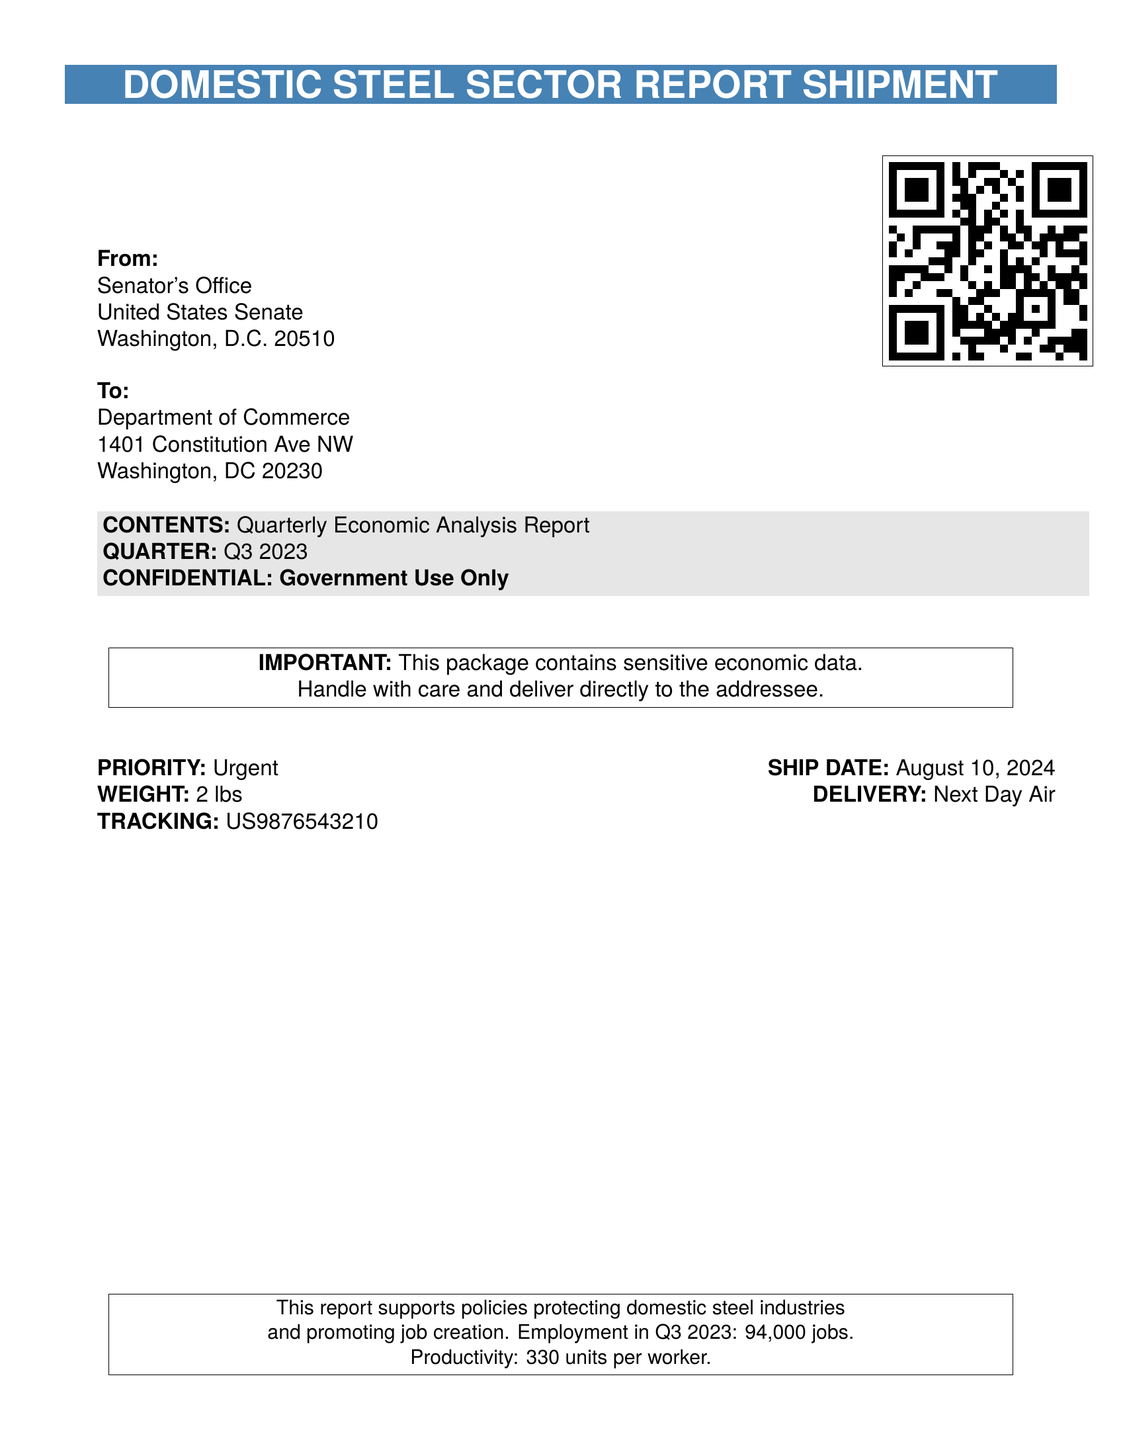what is the quarter of the report? The document specifies the quarter as Q3 2023.
Answer: Q3 2023 what is the weight of the shipment? The document states the weight of the shipment is 2 lbs.
Answer: 2 lbs who is the sender of the report? The sender, as indicated in the document, is the Senator's Office.
Answer: Senator's Office what is the employment figure for Q3 2023? The document mentions the employment figure as 94,000 jobs.
Answer: 94,000 jobs what is the productivity metric mentioned? The productivity metric stated in the document is 330 units per worker.
Answer: 330 units per worker who is the recipient of the report? The report is addressed to the Department of Commerce.
Answer: Department of Commerce what is the shipping date of the report? The shipping date is indicated as today's date, which is the day of the printing.
Answer: today's date what is the shipping priority? The document indicates that the shipping priority is Urgent.
Answer: Urgent what type of document is this? The document is a Shipping Label.
Answer: Shipping Label 